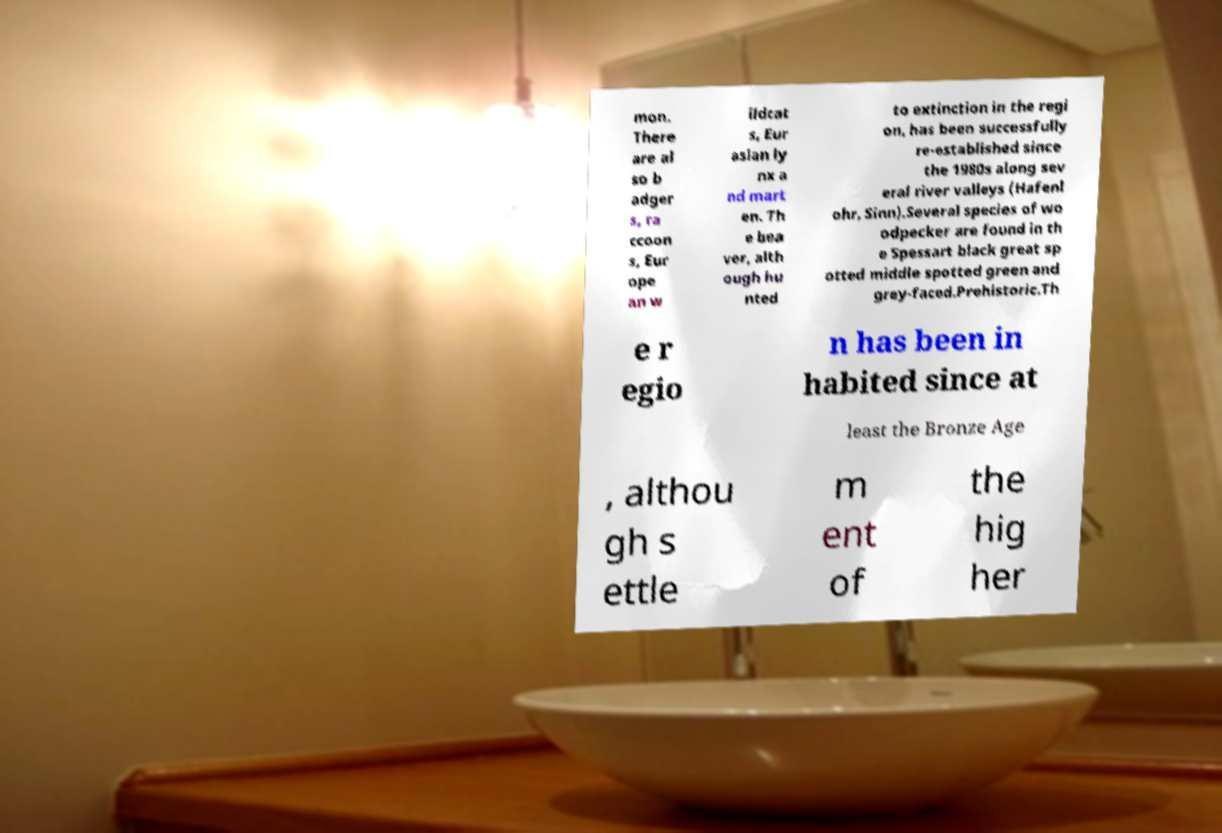Can you read and provide the text displayed in the image?This photo seems to have some interesting text. Can you extract and type it out for me? mon. There are al so b adger s, ra ccoon s, Eur ope an w ildcat s, Eur asian ly nx a nd mart en. Th e bea ver, alth ough hu nted to extinction in the regi on, has been successfully re-established since the 1980s along sev eral river valleys (Hafenl ohr, Sinn).Several species of wo odpecker are found in th e Spessart black great sp otted middle spotted green and grey-faced.Prehistoric.Th e r egio n has been in habited since at least the Bronze Age , althou gh s ettle m ent of the hig her 